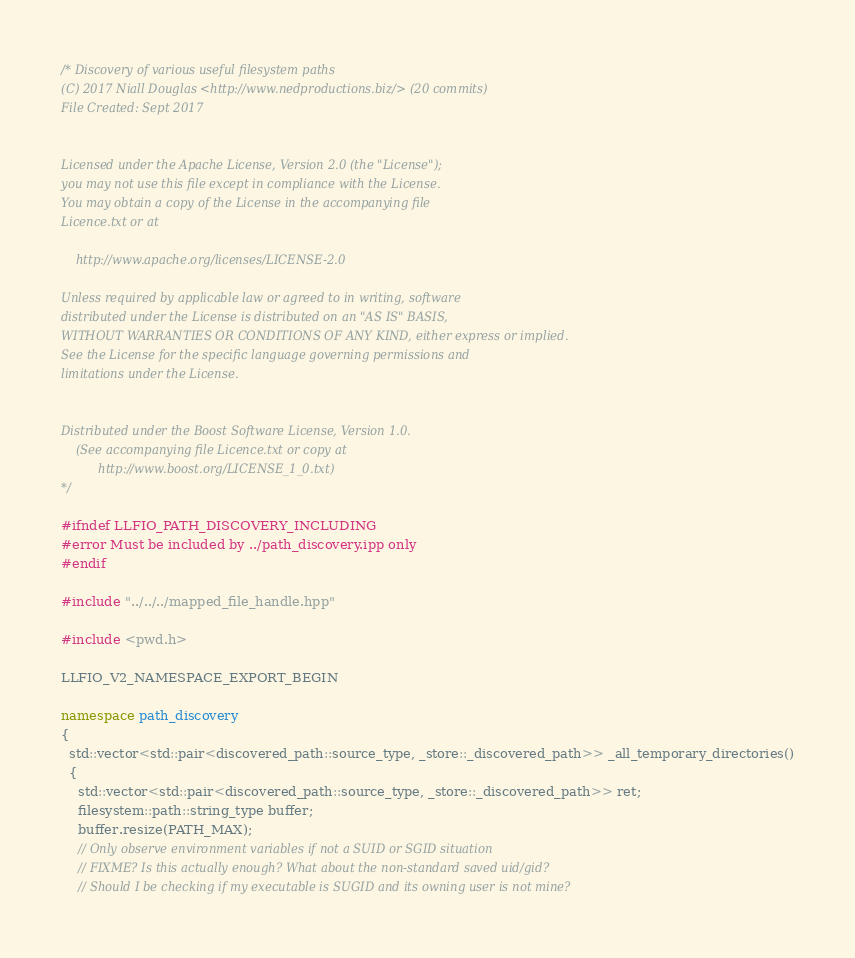<code> <loc_0><loc_0><loc_500><loc_500><_C++_>/* Discovery of various useful filesystem paths
(C) 2017 Niall Douglas <http://www.nedproductions.biz/> (20 commits)
File Created: Sept 2017


Licensed under the Apache License, Version 2.0 (the "License");
you may not use this file except in compliance with the License.
You may obtain a copy of the License in the accompanying file
Licence.txt or at

    http://www.apache.org/licenses/LICENSE-2.0

Unless required by applicable law or agreed to in writing, software
distributed under the License is distributed on an "AS IS" BASIS,
WITHOUT WARRANTIES OR CONDITIONS OF ANY KIND, either express or implied.
See the License for the specific language governing permissions and
limitations under the License.


Distributed under the Boost Software License, Version 1.0.
    (See accompanying file Licence.txt or copy at
          http://www.boost.org/LICENSE_1_0.txt)
*/

#ifndef LLFIO_PATH_DISCOVERY_INCLUDING
#error Must be included by ../path_discovery.ipp only
#endif

#include "../../../mapped_file_handle.hpp"

#include <pwd.h>

LLFIO_V2_NAMESPACE_EXPORT_BEGIN

namespace path_discovery
{
  std::vector<std::pair<discovered_path::source_type, _store::_discovered_path>> _all_temporary_directories()
  {
    std::vector<std::pair<discovered_path::source_type, _store::_discovered_path>> ret;
    filesystem::path::string_type buffer;
    buffer.resize(PATH_MAX);
    // Only observe environment variables if not a SUID or SGID situation
    // FIXME? Is this actually enough? What about the non-standard saved uid/gid?
    // Should I be checking if my executable is SUGID and its owning user is not mine?</code> 